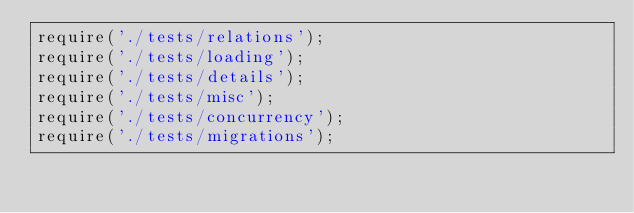Convert code to text. <code><loc_0><loc_0><loc_500><loc_500><_JavaScript_>require('./tests/relations');
require('./tests/loading');
require('./tests/details');
require('./tests/misc');
require('./tests/concurrency');
require('./tests/migrations');
</code> 